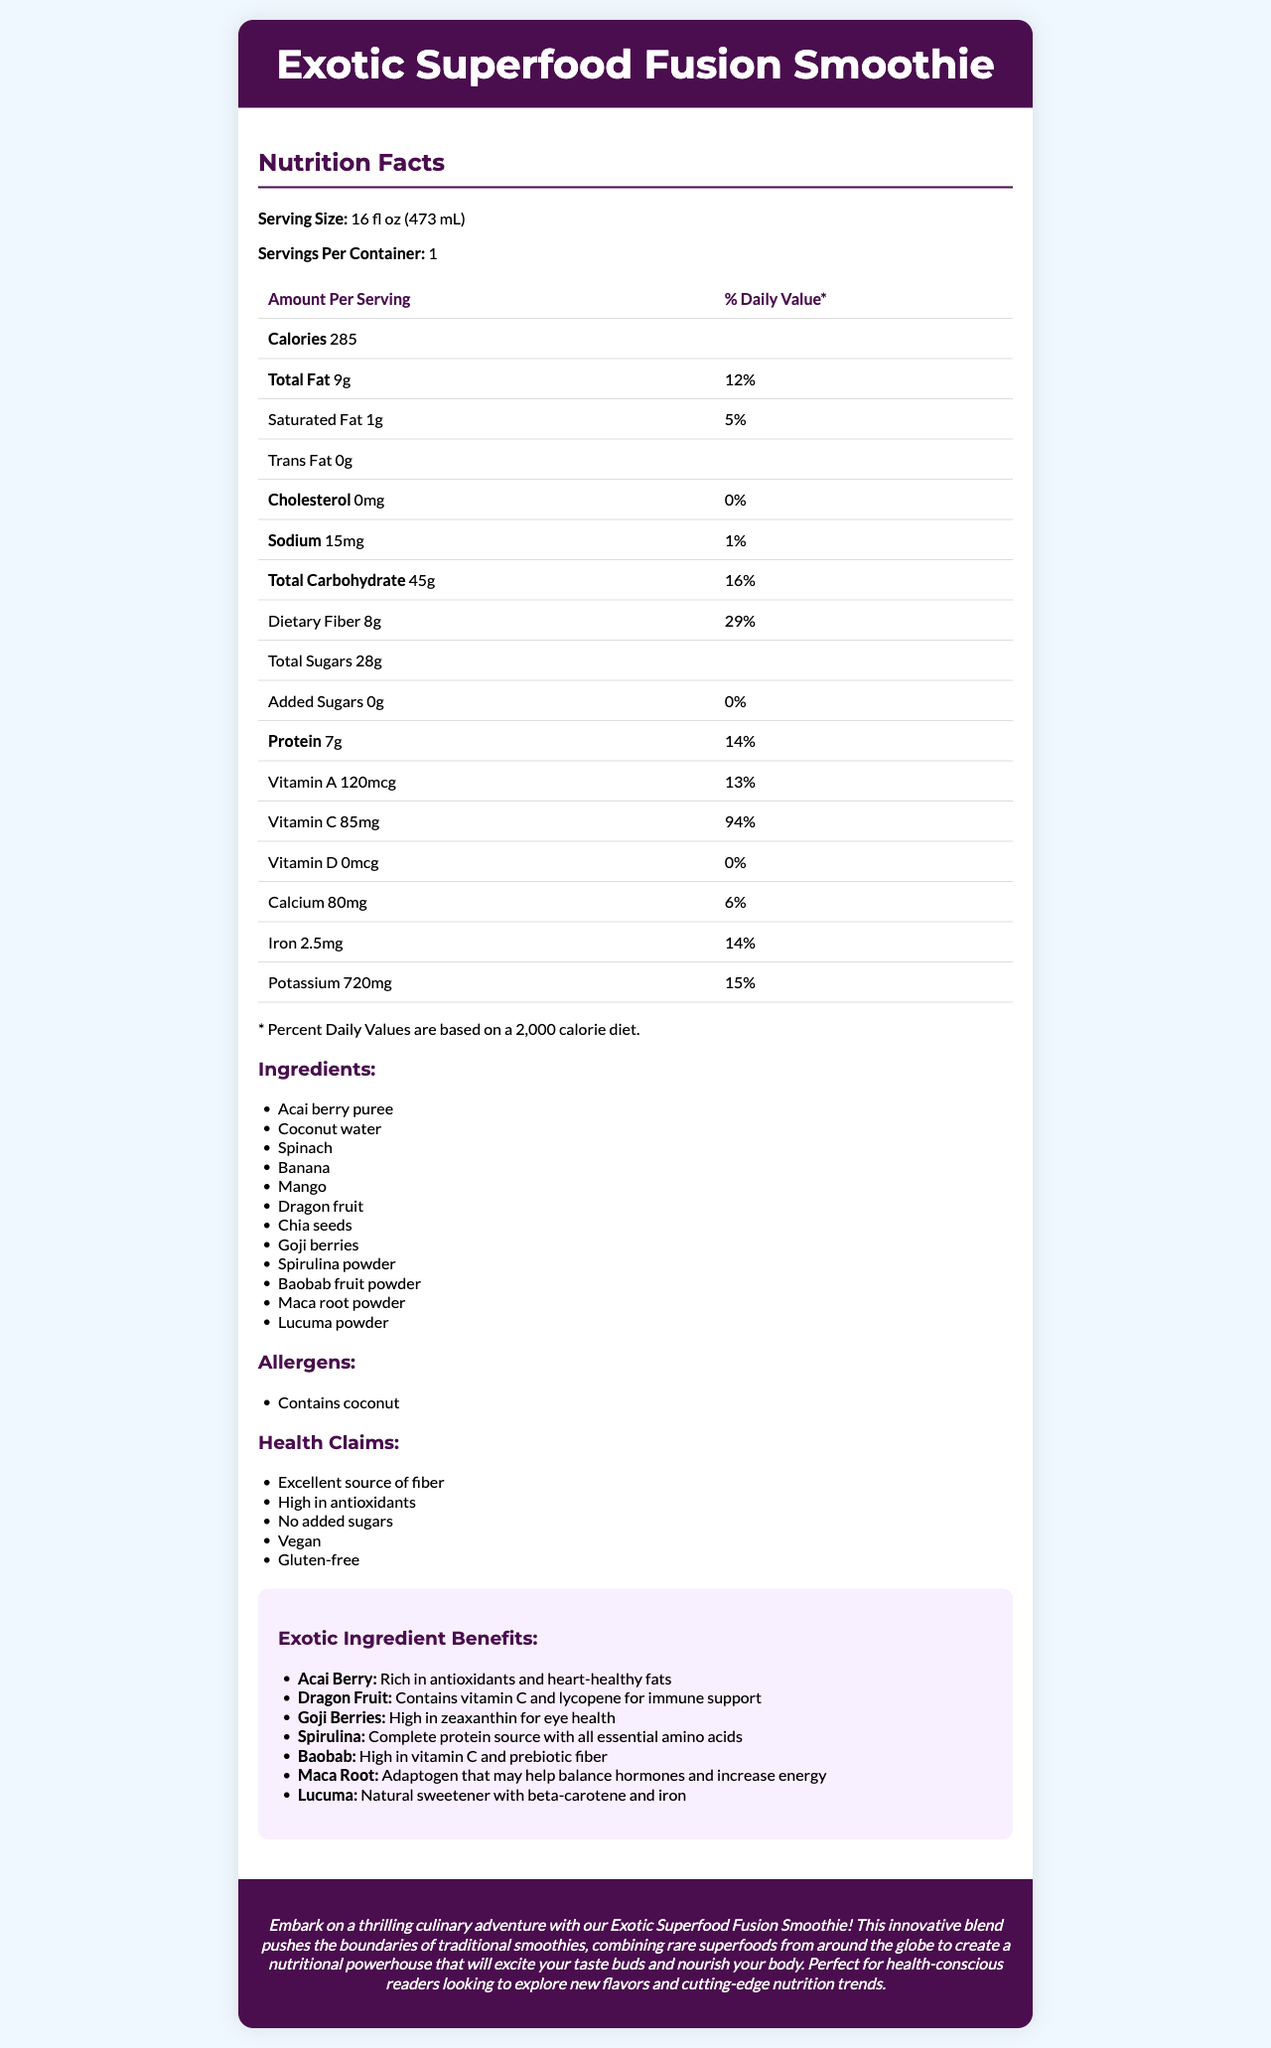what is the serving size of the Exotic Superfood Fusion Smoothie? The serving size is specified under "Serving Size" in the Nutrition Facts section.
Answer: 16 fl oz (473 mL) how many calories are in one serving of this smoothie? The number of calories is listed under "Calories" in the Nutrition Facts section.
Answer: 285 which vitamin has the highest daily value percentage? Vitamin C has a daily value percentage of 94%, which is the highest among all the listed vitamins and minerals.
Answer: Vitamin C what is the total fat content in one serving? The total fat content is specified under "Total Fat" in the Nutrition Facts section and amounts to 9 grams.
Answer: 9g how much protein is there in one serving? The amount of protein is listed in the Nutrition Facts section under "Protein" and amounts to 7 grams.
Answer: 7g which ingredient is high in zeaxanthin for eye health? A. Acai berry B. Dragon fruit C. Goji berries The exotic ingredient benefits section lists goji berries as "High in zeaxanthin for eye health."
Answer: C what is the daily value percentage for dietary fiber? A. 12% B. 16% C. 29% The daily value percentage for dietary fiber is listed as 29% in the Nutrition Facts section.
Answer: C which health claim is NOT listed for this smoothie? A. High in antioxidants B. Contains added sugars C. Vegan The health claims list includes "High in antioxidants" and "Vegan," but "Contains added sugars" is not listed.
Answer: B is this smoothie gluten-free? The health claims section includes "Gluten-free," indicating the smoothie is gluten-free.
Answer: Yes does the smoothie contain any cholesterol? The Nutrition Facts section specifies that the amount of cholesterol is 0mg, with a daily value percentage of 0%.
Answer: No which superfood is high in vitamin C and lycopene? The exotic ingredient benefits section describes dragon fruit as containing vitamin C and lycopene for immune support.
Answer: Dragon fruit describe the main idea of the document. The document details the nutritional information per serving, the exotic ingredients used along with their health benefits, and describes the smoothie as a health-conscious choice for exploring new flavors and nutrition trends.
Answer: The document provides a comprehensive overview of the nutritional breakdown, ingredients, health benefits, and marketing information for the Exotic Superfood Fusion Smoothie. It highlights the serving size, calorie content, macronutrient and micronutrient information, and benefits of the exotic ingredients used in the smoothie. Additionally, it mentions specific health claims and allergens related to the product. how much potassium is in one serving? The amount of potassium is listed in the Nutrition Facts section, indicated as 720mg.
Answer: 720mg can we determine the cost of the smoothie from the document? The document focuses on the nutritional information, ingredients, and health benefits but does not provide any details regarding the cost or price of the smoothie.
Answer: Cannot be determined is there any added sugar in the smoothie? The Nutrition Facts section indicates that the amount of added sugars is 0g.
Answer: No which ingredient provides heart-healthy fats and is rich in antioxidants? The exotic ingredient benefits section lists acai berry puree as rich in antioxidants and heart-healthy fats.
Answer: Acai berry puree 